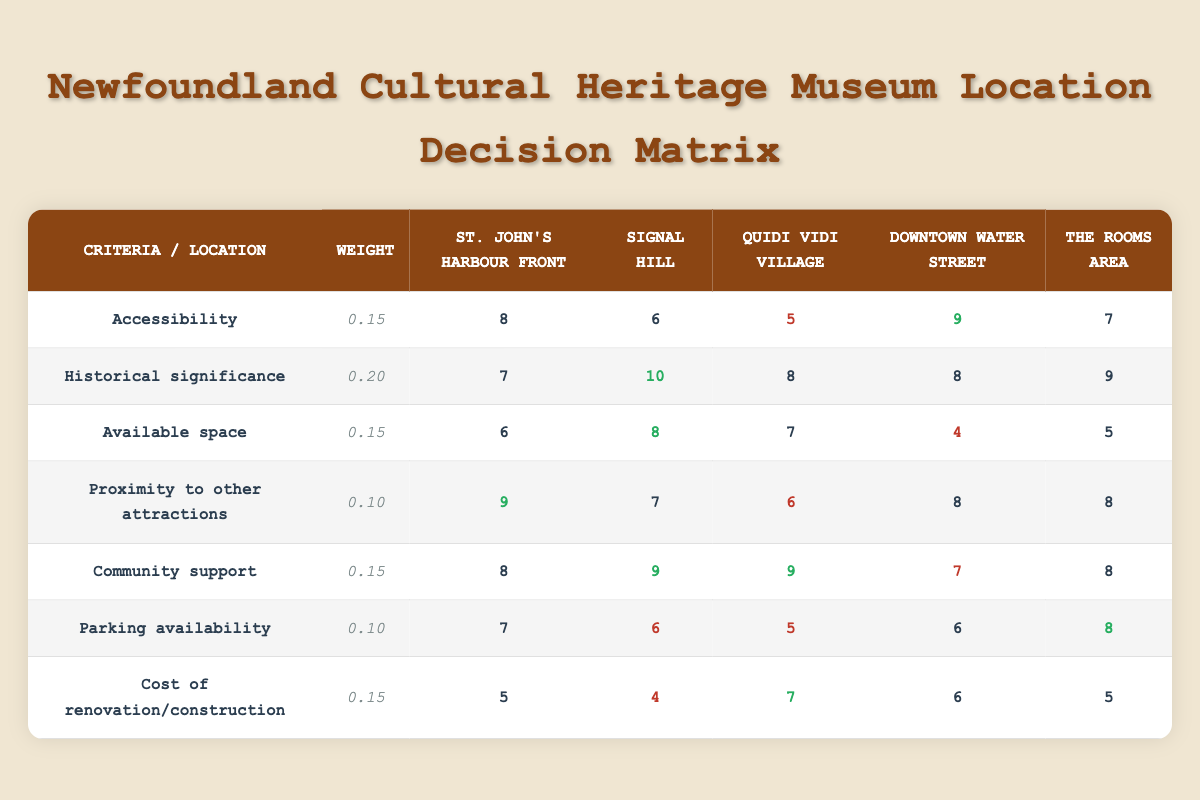What is the score for Accessibility at St. John's Harbour Front? The score for Accessibility in the St. John's Harbour Front row is 8.
Answer: 8 Which location has the highest score for Community support? The score for Community support is highest for Signal Hill and Quidi Vidi Village, both with a score of 9.
Answer: 9 What is the average score for Historical significance across all locations? The scores for Historical significance are 7, 10, 8, 8, and 9. Their sum is 52. There are 5 locations, so the average is 52/5 = 10.4.
Answer: 10.4 Is Downtown Water Street the location with the lowest score for Available space? The scores for Available space are 6 for St. John's Harbour Front, 8 for Signal Hill, 7 for Quidi Vidi Village, 4 for Downtown Water Street, and 5 for The Rooms area. Downtown Water Street indeed has the lowest score with 4.
Answer: Yes Which location has the lowest overall score for Parking availability and what is that score? The scores for Parking availability are 7 for St. John's Harbour Front, 6 for Signal Hill, 5 for Quidi Vidi Village, 6 for Downtown Water Street, and 8 for The Rooms area. Quidi Vidi Village has the lowest score with 5.
Answer: 5 What is the total weighted score for The Rooms area? The individual scores for The Rooms area are: Accessibility (7), Historical significance (9), Available space (5), Proximity to other attractions (8), Community support (8), Parking availability (8), Cost of renovation/construction (5). Applying the weights: (7*0.15) + (9*0.20) + (5*0.15) + (8*0.10) + (8*0.15) + (8*0.10) + (5*0.15) = 1.05 + 1.8 + 0.75 + 0.8 + 1.2 + 0.8 + 0.75 = 6.15.
Answer: 6.15 How many locations scored higher than 6 in the Proximity to other attractions criterion? The scores for Proximity to other attractions are: 9 for St. John's Harbour Front, 7 for Signal Hill, 6 for Quidi Vidi Village, 8 for Downtown Water Street, and 8 for The Rooms area. St. John's Harbour Front, Signal Hill, Downtown Water Street, and The Rooms area all scored higher than 6, totaling 4 locations.
Answer: 4 Is there any location that scores the same for both Parking availability and Cost of renovation/construction? The scores for Parking availability are 7 for St. John's Harbour Front, 6 for Signal Hill, 5 for Quidi Vidi Village, 6 for Downtown Water Street, and 8 for The Rooms area. The scores for Cost of renovation/construction are 5 for St. John's Harbour Front, 4 for Signal Hill, 7 for Quidi Vidi Village, 6 for Downtown Water Street, and 5 for The Rooms area. St. John's Harbour Front and Downtown Water Street both have Parking availability of 6 and Cost of renovation/construction of 6.
Answer: Yes Which two locations scored the highest in Historical significance and what are their scores? The scores for Historical significance are 7 for St. John's Harbour Front, 10 for Signal Hill, 8 for Quidi Vidi Village, 8 for Downtown Water Street, and 9 for The Rooms area. Signal Hill has the highest score of 10, followed by The Rooms area with a score of 9.
Answer: 10 and 9 